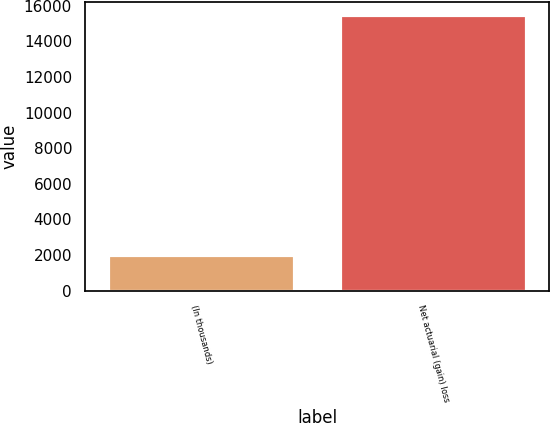<chart> <loc_0><loc_0><loc_500><loc_500><bar_chart><fcel>(In thousands)<fcel>Net actuarial (gain) loss<nl><fcel>2014<fcel>15465<nl></chart> 